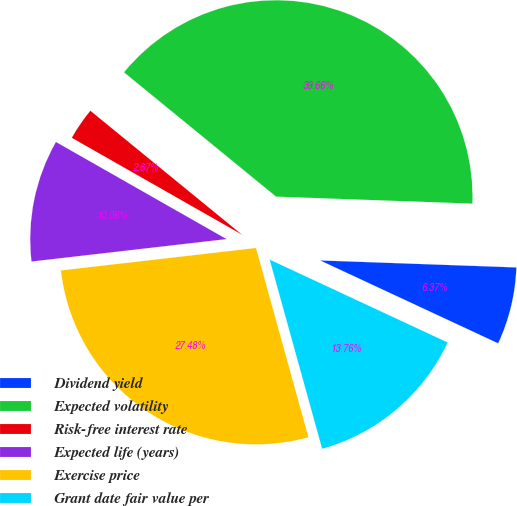Convert chart. <chart><loc_0><loc_0><loc_500><loc_500><pie_chart><fcel>Dividend yield<fcel>Expected volatility<fcel>Risk-free interest rate<fcel>Expected life (years)<fcel>Exercise price<fcel>Grant date fair value per<nl><fcel>6.37%<fcel>39.66%<fcel>2.67%<fcel>10.06%<fcel>27.48%<fcel>13.76%<nl></chart> 